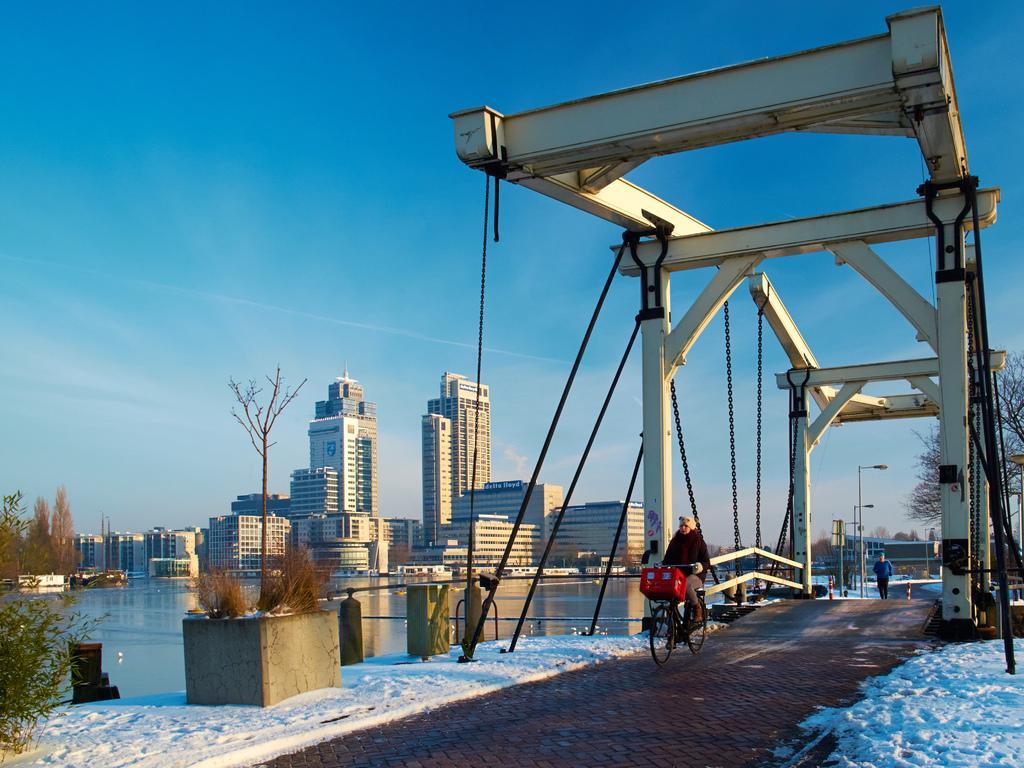Describe this image in one or two sentences. In this image we can see a person riding bicycle and a person walking on the floor. In the background there are bridge, chains, plants, trees, buildings, street poles, street lights, snow, water and sky with clouds. 